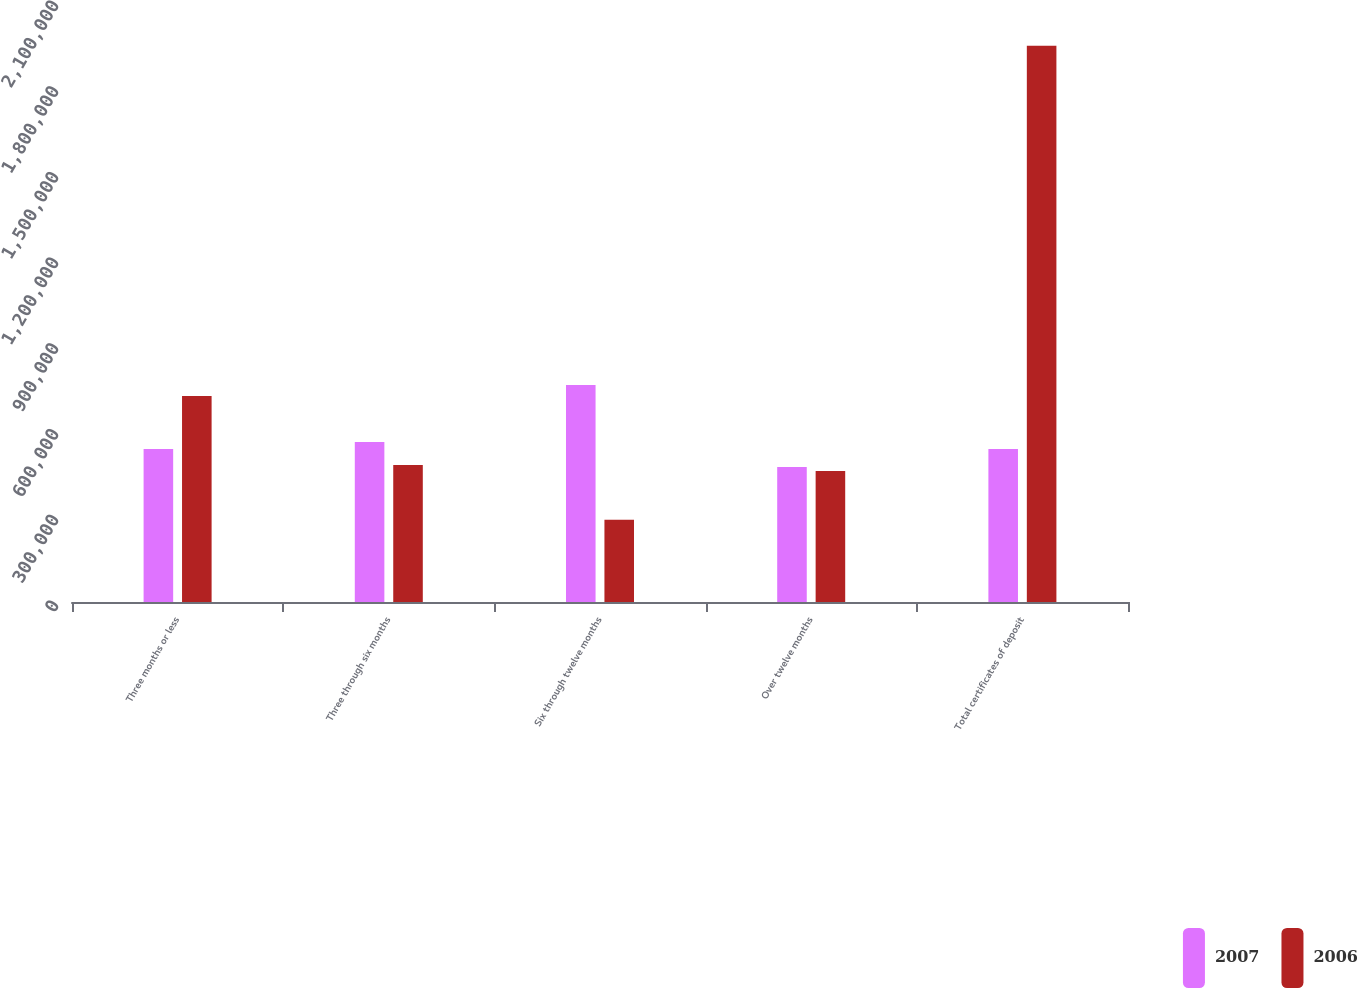Convert chart. <chart><loc_0><loc_0><loc_500><loc_500><stacked_bar_chart><ecel><fcel>Three months or less<fcel>Three through six months<fcel>Six through twelve months<fcel>Over twelve months<fcel>Total certificates of deposit<nl><fcel>2007<fcel>535290<fcel>560121<fcel>759840<fcel>472836<fcel>535290<nl><fcel>2006<fcel>721392<fcel>479166<fcel>287593<fcel>458292<fcel>1.94644e+06<nl></chart> 